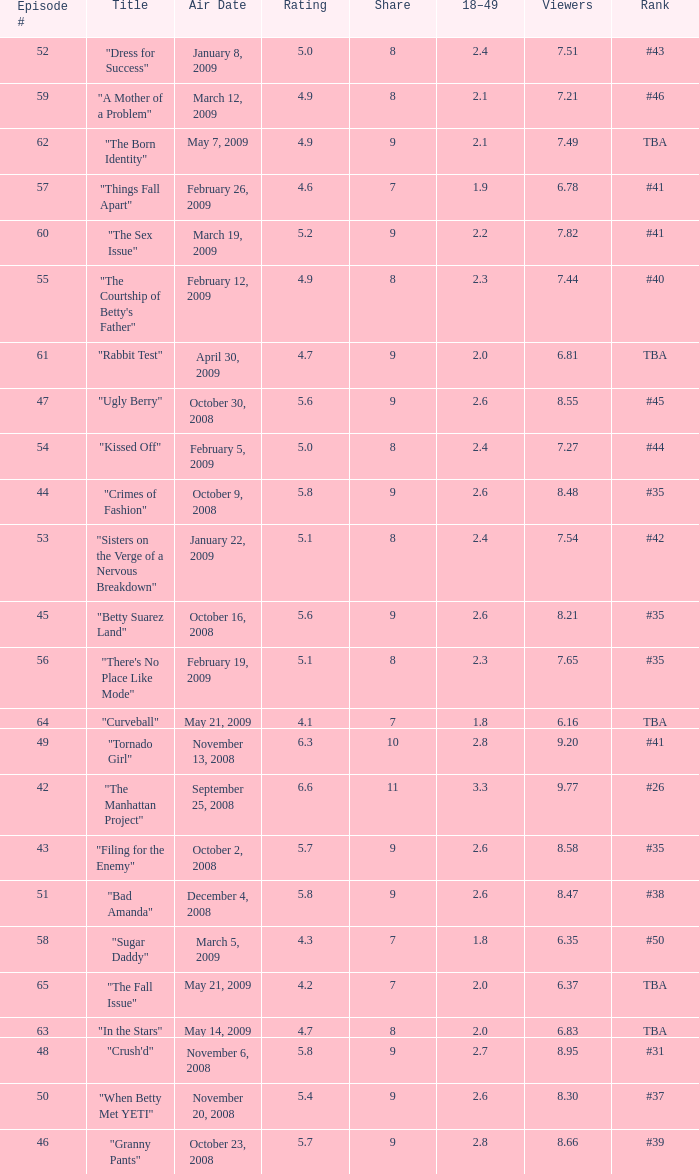What is the average Episode # with a 7 share and 18–49 is less than 2 and the Air Date of may 21, 2009? 64.0. 